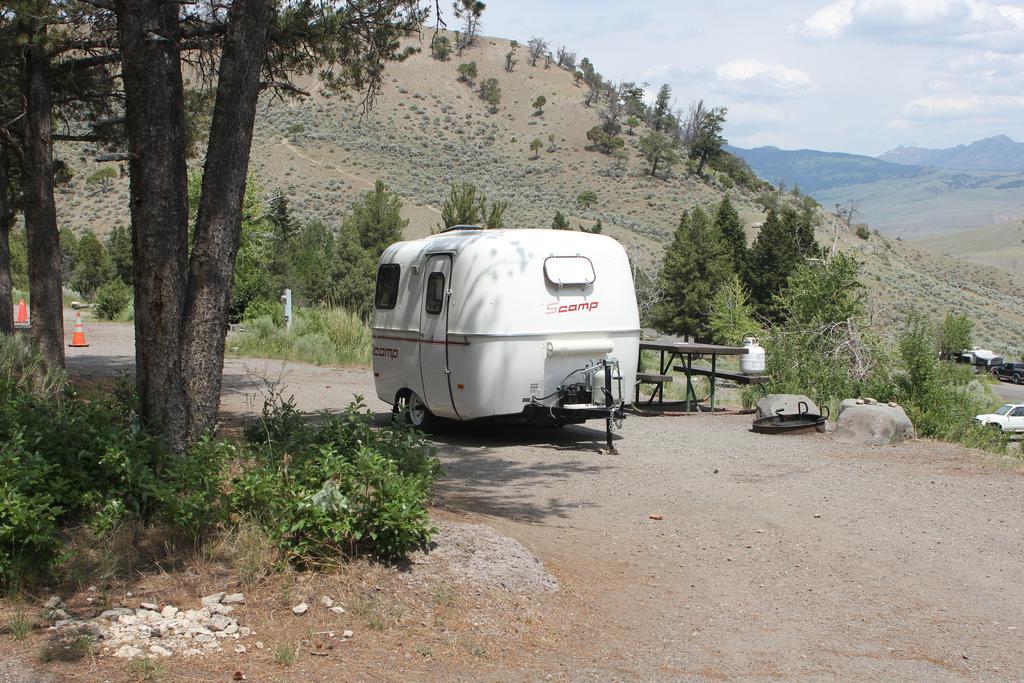Could you give a brief overview of what you see in this image? In this picture there is a white color van which is parked near to the benches and the table. In the background I can see the mountains. On the left there are two traffic cones which are placed near to the plants and grass. In the bottom left corner I can see some stones. On the right I can see the shed, trees and car. At the top I can see the sky and clouds. 